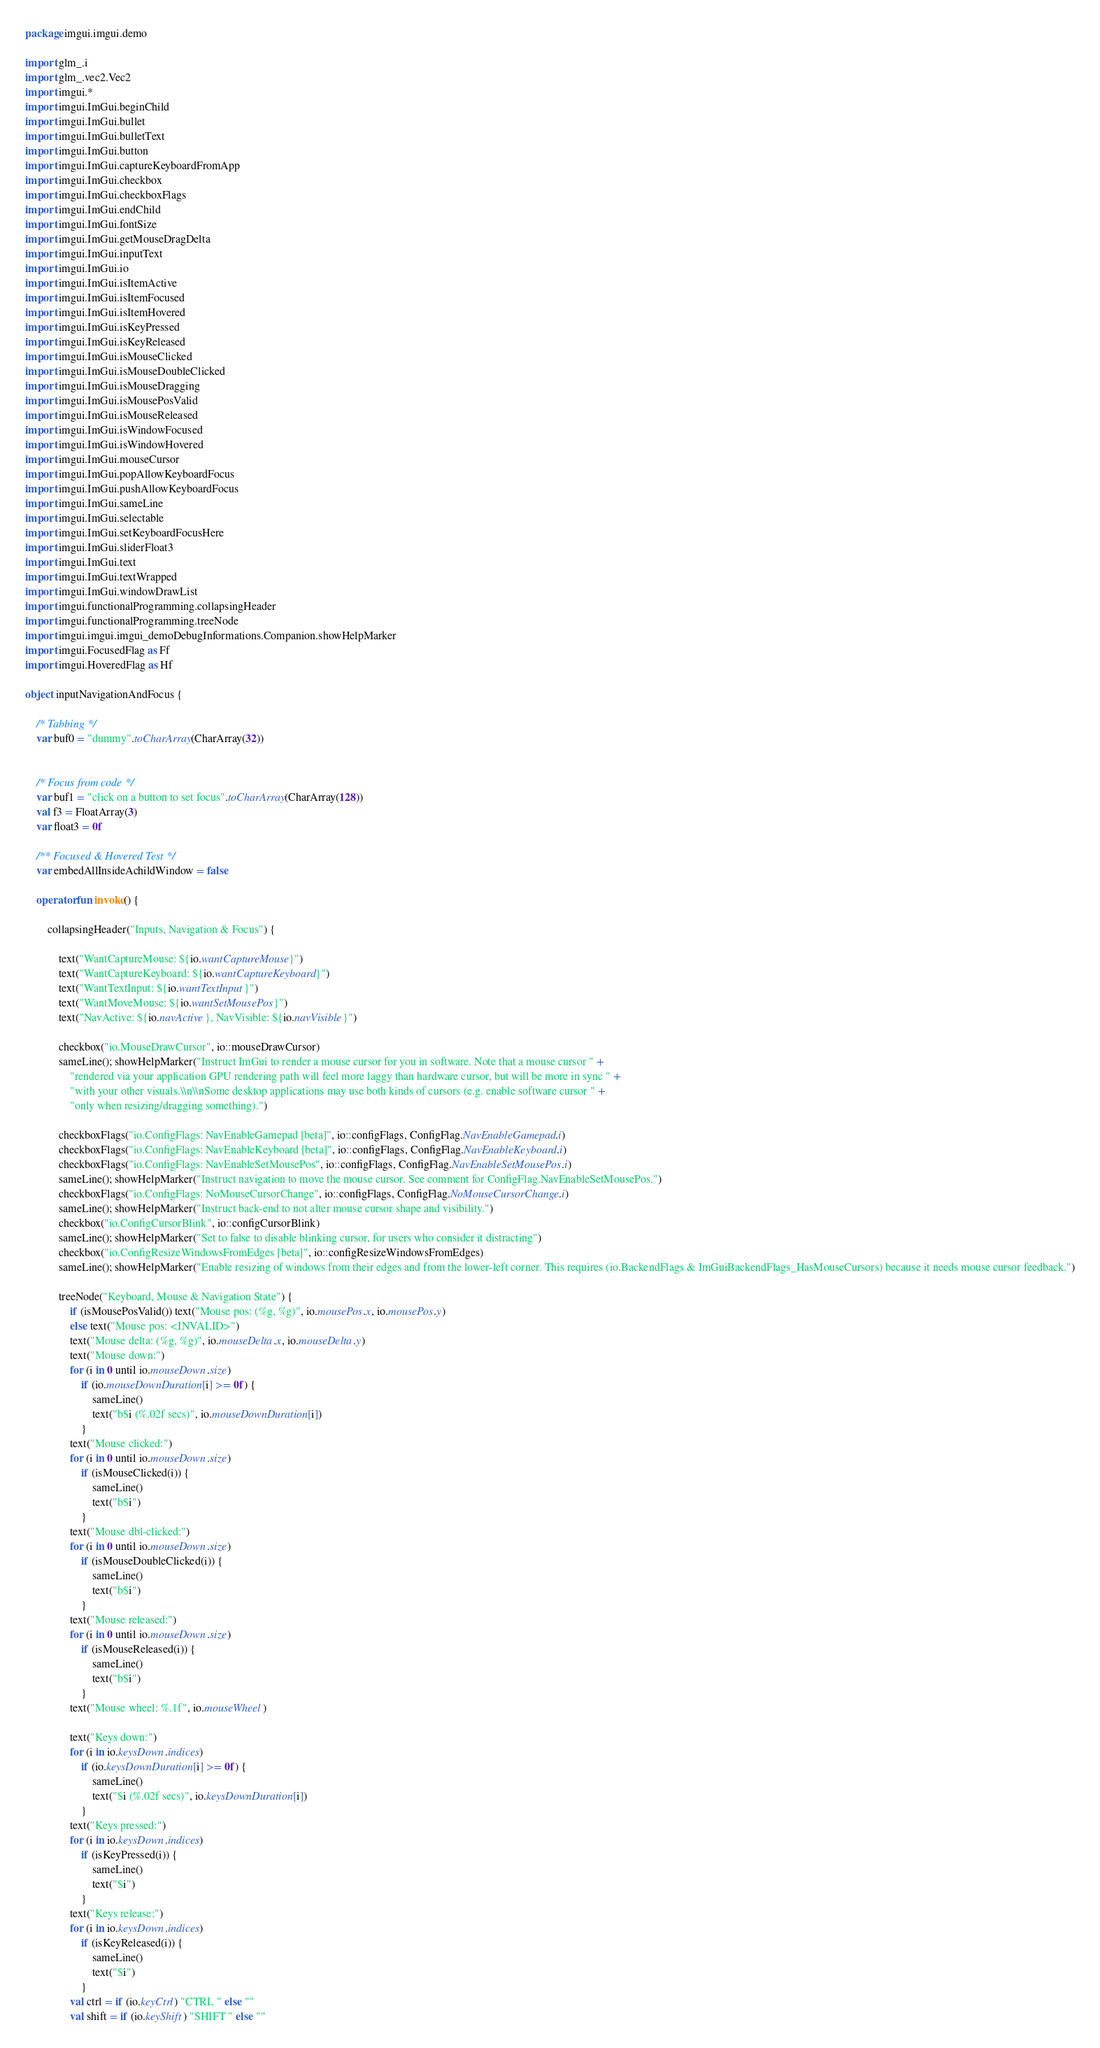<code> <loc_0><loc_0><loc_500><loc_500><_Kotlin_>package imgui.imgui.demo

import glm_.i
import glm_.vec2.Vec2
import imgui.*
import imgui.ImGui.beginChild
import imgui.ImGui.bullet
import imgui.ImGui.bulletText
import imgui.ImGui.button
import imgui.ImGui.captureKeyboardFromApp
import imgui.ImGui.checkbox
import imgui.ImGui.checkboxFlags
import imgui.ImGui.endChild
import imgui.ImGui.fontSize
import imgui.ImGui.getMouseDragDelta
import imgui.ImGui.inputText
import imgui.ImGui.io
import imgui.ImGui.isItemActive
import imgui.ImGui.isItemFocused
import imgui.ImGui.isItemHovered
import imgui.ImGui.isKeyPressed
import imgui.ImGui.isKeyReleased
import imgui.ImGui.isMouseClicked
import imgui.ImGui.isMouseDoubleClicked
import imgui.ImGui.isMouseDragging
import imgui.ImGui.isMousePosValid
import imgui.ImGui.isMouseReleased
import imgui.ImGui.isWindowFocused
import imgui.ImGui.isWindowHovered
import imgui.ImGui.mouseCursor
import imgui.ImGui.popAllowKeyboardFocus
import imgui.ImGui.pushAllowKeyboardFocus
import imgui.ImGui.sameLine
import imgui.ImGui.selectable
import imgui.ImGui.setKeyboardFocusHere
import imgui.ImGui.sliderFloat3
import imgui.ImGui.text
import imgui.ImGui.textWrapped
import imgui.ImGui.windowDrawList
import imgui.functionalProgramming.collapsingHeader
import imgui.functionalProgramming.treeNode
import imgui.imgui.imgui_demoDebugInformations.Companion.showHelpMarker
import imgui.FocusedFlag as Ff
import imgui.HoveredFlag as Hf

object inputNavigationAndFocus {

    /* Tabbing */
    var buf0 = "dummy".toCharArray(CharArray(32))


    /* Focus from code */
    var buf1 = "click on a button to set focus".toCharArray(CharArray(128))
    val f3 = FloatArray(3)
    var float3 = 0f

    /** Focused & Hovered Test */
    var embedAllInsideAchildWindow = false

    operator fun invoke() {

        collapsingHeader("Inputs, Navigation & Focus") {

            text("WantCaptureMouse: ${io.wantCaptureMouse}")
            text("WantCaptureKeyboard: ${io.wantCaptureKeyboard}")
            text("WantTextInput: ${io.wantTextInput}")
            text("WantMoveMouse: ${io.wantSetMousePos}")
            text("NavActive: ${io.navActive}, NavVisible: ${io.navVisible}")

            checkbox("io.MouseDrawCursor", io::mouseDrawCursor)
            sameLine(); showHelpMarker("Instruct ImGui to render a mouse cursor for you in software. Note that a mouse cursor " +
                "rendered via your application GPU rendering path will feel more laggy than hardware cursor, but will be more in sync " +
                "with your other visuals.\\n\\nSome desktop applications may use both kinds of cursors (e.g. enable software cursor " +
                "only when resizing/dragging something).")

            checkboxFlags("io.ConfigFlags: NavEnableGamepad [beta]", io::configFlags, ConfigFlag.NavEnableGamepad.i)
            checkboxFlags("io.ConfigFlags: NavEnableKeyboard [beta]", io::configFlags, ConfigFlag.NavEnableKeyboard.i)
            checkboxFlags("io.ConfigFlags: NavEnableSetMousePos", io::configFlags, ConfigFlag.NavEnableSetMousePos.i)
            sameLine(); showHelpMarker("Instruct navigation to move the mouse cursor. See comment for ConfigFlag.NavEnableSetMousePos.")
            checkboxFlags("io.ConfigFlags: NoMouseCursorChange", io::configFlags, ConfigFlag.NoMouseCursorChange.i)
            sameLine(); showHelpMarker("Instruct back-end to not alter mouse cursor shape and visibility.")
            checkbox("io.ConfigCursorBlink", io::configCursorBlink)
            sameLine(); showHelpMarker("Set to false to disable blinking cursor, for users who consider it distracting")
            checkbox("io.ConfigResizeWindowsFromEdges [beta]", io::configResizeWindowsFromEdges)
            sameLine(); showHelpMarker("Enable resizing of windows from their edges and from the lower-left corner. This requires (io.BackendFlags & ImGuiBackendFlags_HasMouseCursors) because it needs mouse cursor feedback.")

            treeNode("Keyboard, Mouse & Navigation State") {
                if (isMousePosValid()) text("Mouse pos: (%g, %g)", io.mousePos.x, io.mousePos.y)
                else text("Mouse pos: <INVALID>")
                text("Mouse delta: (%g, %g)", io.mouseDelta.x, io.mouseDelta.y)
                text("Mouse down:")
                for (i in 0 until io.mouseDown.size)
                    if (io.mouseDownDuration[i] >= 0f) {
                        sameLine()
                        text("b$i (%.02f secs)", io.mouseDownDuration[i])
                    }
                text("Mouse clicked:")
                for (i in 0 until io.mouseDown.size)
                    if (isMouseClicked(i)) {
                        sameLine()
                        text("b$i")
                    }
                text("Mouse dbl-clicked:")
                for (i in 0 until io.mouseDown.size)
                    if (isMouseDoubleClicked(i)) {
                        sameLine()
                        text("b$i")
                    }
                text("Mouse released:")
                for (i in 0 until io.mouseDown.size)
                    if (isMouseReleased(i)) {
                        sameLine()
                        text("b$i")
                    }
                text("Mouse wheel: %.1f", io.mouseWheel)

                text("Keys down:")
                for (i in io.keysDown.indices)
                    if (io.keysDownDuration[i] >= 0f) {
                        sameLine()
                        text("$i (%.02f secs)", io.keysDownDuration[i])
                    }
                text("Keys pressed:")
                for (i in io.keysDown.indices)
                    if (isKeyPressed(i)) {
                        sameLine()
                        text("$i")
                    }
                text("Keys release:")
                for (i in io.keysDown.indices)
                    if (isKeyReleased(i)) {
                        sameLine()
                        text("$i")
                    }
                val ctrl = if (io.keyCtrl) "CTRL " else ""
                val shift = if (io.keyShift) "SHIFT " else ""</code> 